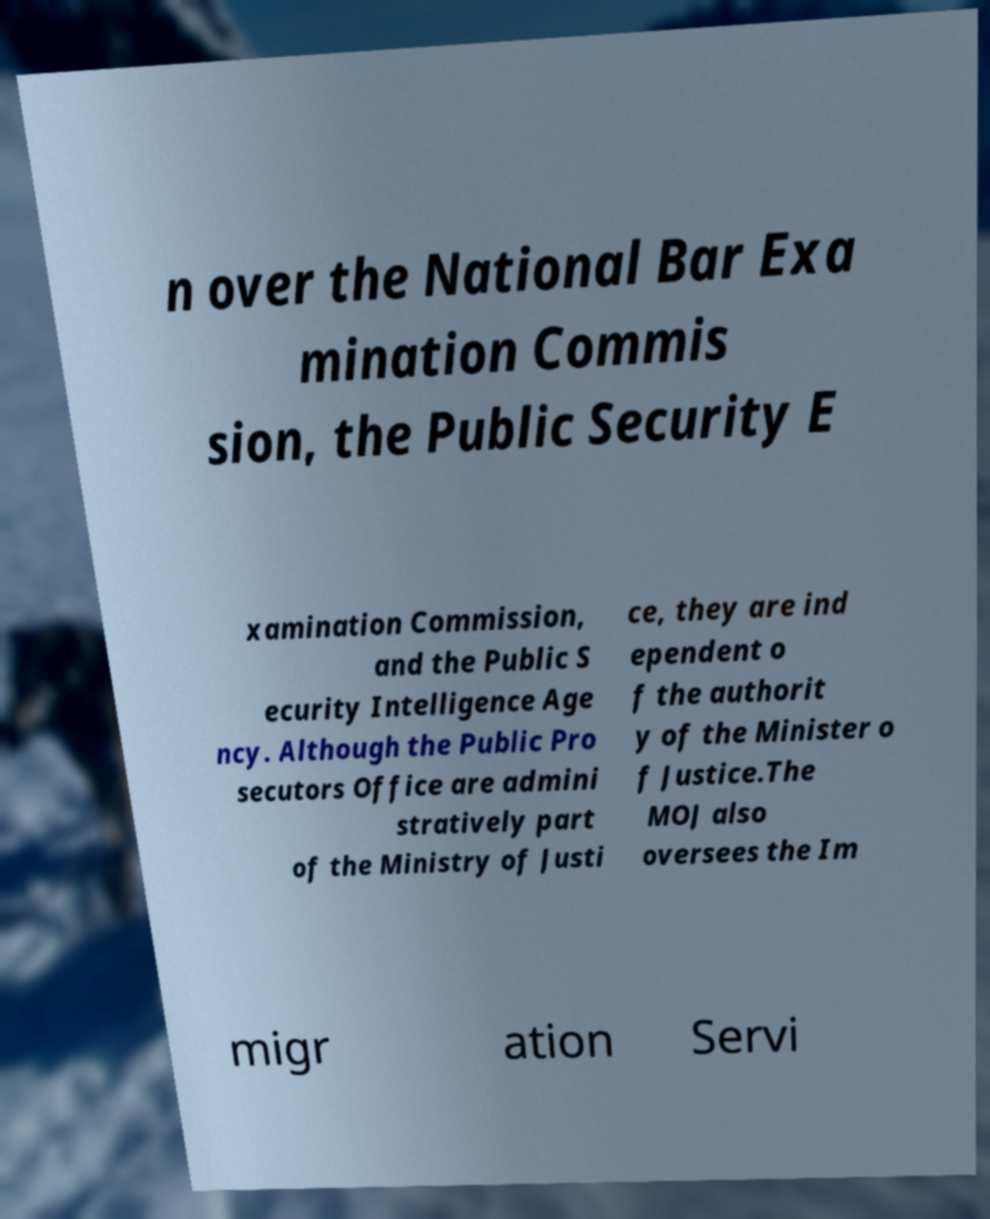Please read and relay the text visible in this image. What does it say? n over the National Bar Exa mination Commis sion, the Public Security E xamination Commission, and the Public S ecurity Intelligence Age ncy. Although the Public Pro secutors Office are admini stratively part of the Ministry of Justi ce, they are ind ependent o f the authorit y of the Minister o f Justice.The MOJ also oversees the Im migr ation Servi 